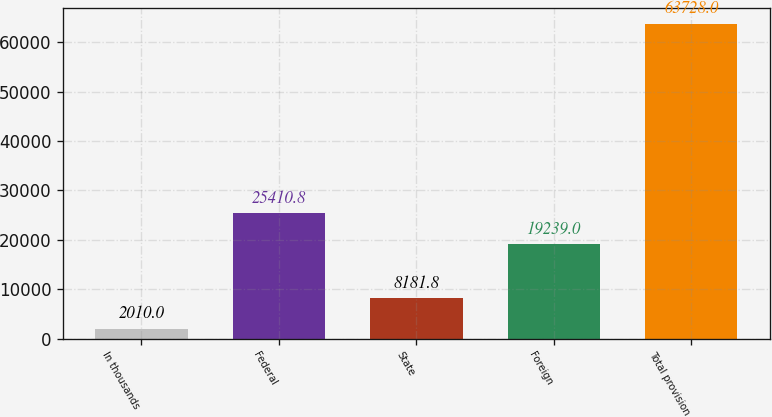<chart> <loc_0><loc_0><loc_500><loc_500><bar_chart><fcel>In thousands<fcel>Federal<fcel>State<fcel>Foreign<fcel>Total provision<nl><fcel>2010<fcel>25410.8<fcel>8181.8<fcel>19239<fcel>63728<nl></chart> 